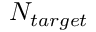<formula> <loc_0><loc_0><loc_500><loc_500>N _ { t \arg e t }</formula> 